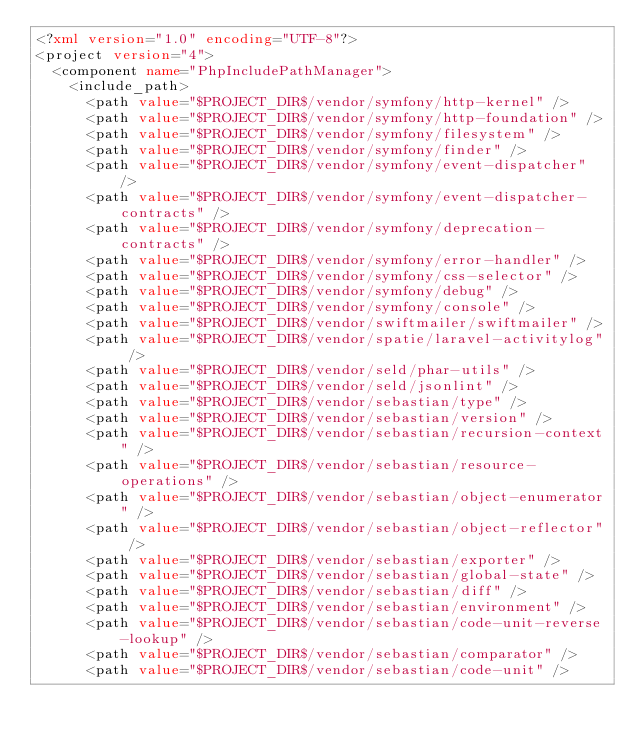Convert code to text. <code><loc_0><loc_0><loc_500><loc_500><_XML_><?xml version="1.0" encoding="UTF-8"?>
<project version="4">
  <component name="PhpIncludePathManager">
    <include_path>
      <path value="$PROJECT_DIR$/vendor/symfony/http-kernel" />
      <path value="$PROJECT_DIR$/vendor/symfony/http-foundation" />
      <path value="$PROJECT_DIR$/vendor/symfony/filesystem" />
      <path value="$PROJECT_DIR$/vendor/symfony/finder" />
      <path value="$PROJECT_DIR$/vendor/symfony/event-dispatcher" />
      <path value="$PROJECT_DIR$/vendor/symfony/event-dispatcher-contracts" />
      <path value="$PROJECT_DIR$/vendor/symfony/deprecation-contracts" />
      <path value="$PROJECT_DIR$/vendor/symfony/error-handler" />
      <path value="$PROJECT_DIR$/vendor/symfony/css-selector" />
      <path value="$PROJECT_DIR$/vendor/symfony/debug" />
      <path value="$PROJECT_DIR$/vendor/symfony/console" />
      <path value="$PROJECT_DIR$/vendor/swiftmailer/swiftmailer" />
      <path value="$PROJECT_DIR$/vendor/spatie/laravel-activitylog" />
      <path value="$PROJECT_DIR$/vendor/seld/phar-utils" />
      <path value="$PROJECT_DIR$/vendor/seld/jsonlint" />
      <path value="$PROJECT_DIR$/vendor/sebastian/type" />
      <path value="$PROJECT_DIR$/vendor/sebastian/version" />
      <path value="$PROJECT_DIR$/vendor/sebastian/recursion-context" />
      <path value="$PROJECT_DIR$/vendor/sebastian/resource-operations" />
      <path value="$PROJECT_DIR$/vendor/sebastian/object-enumerator" />
      <path value="$PROJECT_DIR$/vendor/sebastian/object-reflector" />
      <path value="$PROJECT_DIR$/vendor/sebastian/exporter" />
      <path value="$PROJECT_DIR$/vendor/sebastian/global-state" />
      <path value="$PROJECT_DIR$/vendor/sebastian/diff" />
      <path value="$PROJECT_DIR$/vendor/sebastian/environment" />
      <path value="$PROJECT_DIR$/vendor/sebastian/code-unit-reverse-lookup" />
      <path value="$PROJECT_DIR$/vendor/sebastian/comparator" />
      <path value="$PROJECT_DIR$/vendor/sebastian/code-unit" /></code> 